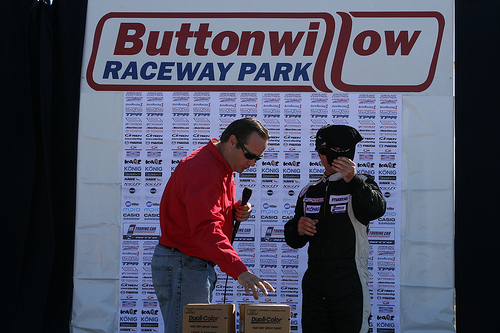<image>
Can you confirm if the man is to the left of the man? Yes. From this viewpoint, the man is positioned to the left side relative to the man. 